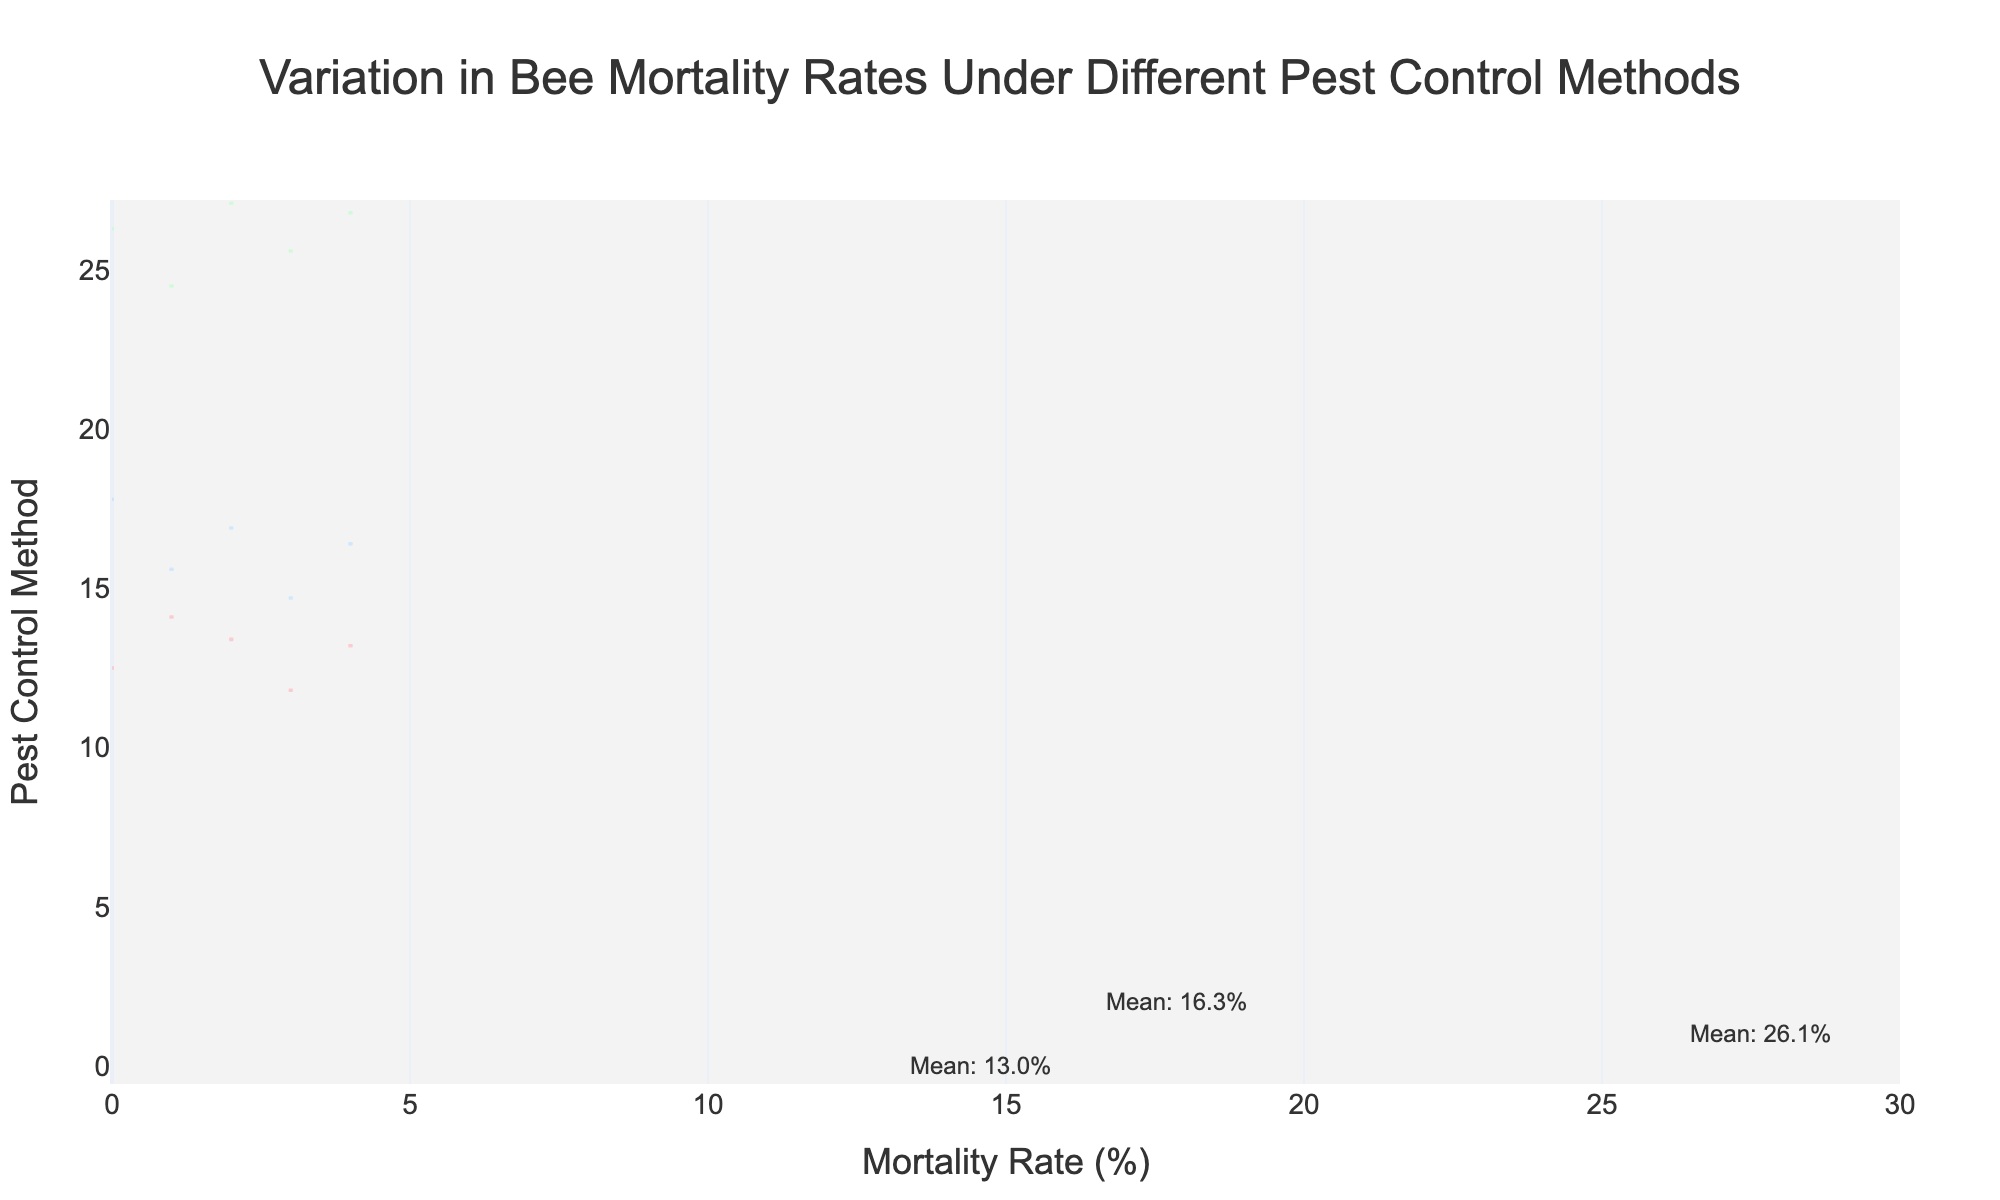What is the title of the figure? The title is displayed prominently at the top of the figure. It reads "Variation in Bee Mortality Rates Under Different Pest Control Methods"
Answer: Variation in Bee Mortality Rates Under Different Pest Control Methods What is the horizontal axis representing? The axis labels provide this information. The horizontal axis represents the "Mortality Rate (%)" of bees.
Answer: Mortality Rate (%) Which pest control method has the highest average bee mortality rate? The annotations on the figure display the mean values for each method. "Synthetic Chemical" has the highest average mortality rate indicated by its highest mean value annotation.
Answer: Synthetic Chemical What is the average mortality rate for the Organic Acid method? The annotation next to the Organic Acid method gives the mean value. The mean mortality rate is 13.0%.
Answer: 13.0% How does the average mortality rate of Essential Oils compare to Synthetic Chemicals? The mean mortality rates are annotated next to each method. Essential Oils have a mean mortality rate of 16.3%, whereas Synthetic Chemicals have a mean of 26.1%. Essential Oils has a lower average mortality rate.
Answer: Essential Oils has a lower average mortality rate Which pest control method has the lowest variability in mortality rates? The spread (width) of the violin plots indicates variability. The narrower the plot, the lower the variability. Organic Acid has the narrowest violin plot, suggesting the lowest variability.
Answer: Organic Acid By how much does the average mortality rate of Synthetic Chemicals exceed that of Organic Acid? The annotations indicate the mean values. Subtract the mean mortality rate of Organic Acid (13.0%) from that of Synthetic Chemicals (26.1%) to get the value, i.e., 26.1 - 13.0 = 13.1%.
Answer: 13.1% Which pest control method shows the widest spread in mortality rates? The spread (width) of the violin plots shows the range of mortality rates. The Synthetic Chemicals plot is the widest, indicating the greatest spread.
Answer: Synthetic Chemicals What can be inferred about the consistency of the Essential Oils method in controlling bee mortality? The relatively narrow violin plot for Essential Oils and its mean mortality rate suggest a more consistent performance compared to Synthetic Chemicals, though not as consistent as Organic Acid.
Answer: Consistent but less than Organic Acid 